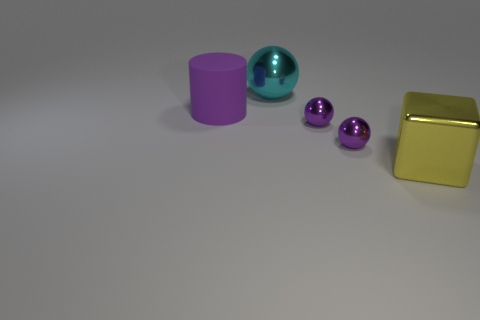Add 3 big cyan metallic balls. How many objects exist? 8 Subtract all cylinders. How many objects are left? 4 Add 5 purple cylinders. How many purple cylinders exist? 6 Subtract 0 purple blocks. How many objects are left? 5 Subtract all balls. Subtract all tiny purple shiny things. How many objects are left? 0 Add 4 big rubber objects. How many big rubber objects are left? 5 